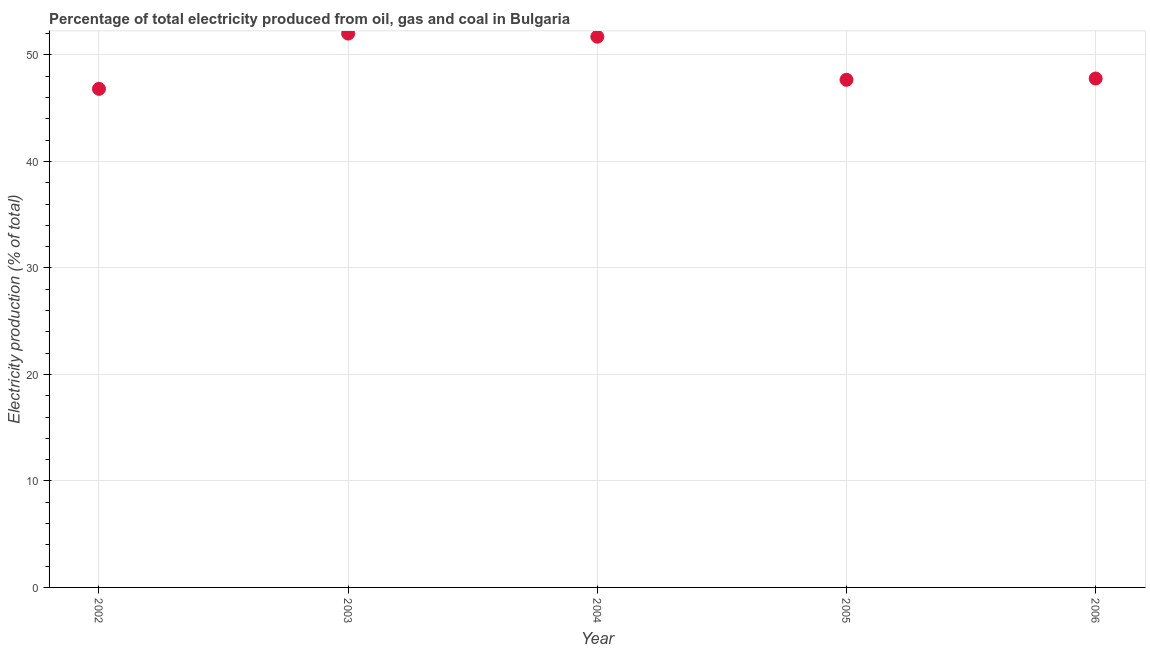What is the electricity production in 2006?
Keep it short and to the point. 47.79. Across all years, what is the maximum electricity production?
Make the answer very short. 52.01. Across all years, what is the minimum electricity production?
Keep it short and to the point. 46.82. In which year was the electricity production maximum?
Provide a short and direct response. 2003. In which year was the electricity production minimum?
Make the answer very short. 2002. What is the sum of the electricity production?
Your answer should be compact. 245.99. What is the difference between the electricity production in 2002 and 2004?
Ensure brevity in your answer.  -4.9. What is the average electricity production per year?
Give a very brief answer. 49.2. What is the median electricity production?
Provide a short and direct response. 47.79. In how many years, is the electricity production greater than 22 %?
Offer a terse response. 5. Do a majority of the years between 2004 and 2003 (inclusive) have electricity production greater than 38 %?
Offer a very short reply. No. What is the ratio of the electricity production in 2002 to that in 2004?
Your response must be concise. 0.91. Is the difference between the electricity production in 2004 and 2006 greater than the difference between any two years?
Your answer should be compact. No. What is the difference between the highest and the second highest electricity production?
Your answer should be very brief. 0.29. Is the sum of the electricity production in 2005 and 2006 greater than the maximum electricity production across all years?
Your answer should be compact. Yes. What is the difference between the highest and the lowest electricity production?
Your answer should be compact. 5.19. In how many years, is the electricity production greater than the average electricity production taken over all years?
Your response must be concise. 2. How many dotlines are there?
Your answer should be compact. 1. How many years are there in the graph?
Offer a terse response. 5. Are the values on the major ticks of Y-axis written in scientific E-notation?
Ensure brevity in your answer.  No. What is the title of the graph?
Ensure brevity in your answer.  Percentage of total electricity produced from oil, gas and coal in Bulgaria. What is the label or title of the Y-axis?
Offer a very short reply. Electricity production (% of total). What is the Electricity production (% of total) in 2002?
Provide a short and direct response. 46.82. What is the Electricity production (% of total) in 2003?
Your response must be concise. 52.01. What is the Electricity production (% of total) in 2004?
Keep it short and to the point. 51.71. What is the Electricity production (% of total) in 2005?
Keep it short and to the point. 47.67. What is the Electricity production (% of total) in 2006?
Offer a very short reply. 47.79. What is the difference between the Electricity production (% of total) in 2002 and 2003?
Your response must be concise. -5.19. What is the difference between the Electricity production (% of total) in 2002 and 2004?
Your response must be concise. -4.9. What is the difference between the Electricity production (% of total) in 2002 and 2005?
Your answer should be very brief. -0.85. What is the difference between the Electricity production (% of total) in 2002 and 2006?
Your answer should be very brief. -0.97. What is the difference between the Electricity production (% of total) in 2003 and 2004?
Give a very brief answer. 0.29. What is the difference between the Electricity production (% of total) in 2003 and 2005?
Make the answer very short. 4.34. What is the difference between the Electricity production (% of total) in 2003 and 2006?
Make the answer very short. 4.22. What is the difference between the Electricity production (% of total) in 2004 and 2005?
Your answer should be very brief. 4.05. What is the difference between the Electricity production (% of total) in 2004 and 2006?
Make the answer very short. 3.93. What is the difference between the Electricity production (% of total) in 2005 and 2006?
Your response must be concise. -0.12. What is the ratio of the Electricity production (% of total) in 2002 to that in 2004?
Provide a short and direct response. 0.91. What is the ratio of the Electricity production (% of total) in 2002 to that in 2005?
Offer a very short reply. 0.98. What is the ratio of the Electricity production (% of total) in 2003 to that in 2005?
Offer a terse response. 1.09. What is the ratio of the Electricity production (% of total) in 2003 to that in 2006?
Keep it short and to the point. 1.09. What is the ratio of the Electricity production (% of total) in 2004 to that in 2005?
Your answer should be very brief. 1.08. What is the ratio of the Electricity production (% of total) in 2004 to that in 2006?
Provide a succinct answer. 1.08. What is the ratio of the Electricity production (% of total) in 2005 to that in 2006?
Ensure brevity in your answer.  1. 